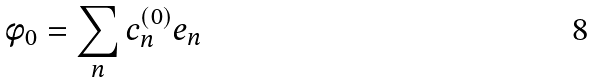Convert formula to latex. <formula><loc_0><loc_0><loc_500><loc_500>\phi _ { 0 } = \sum _ { n } c _ { n } ^ { ( 0 ) } e _ { n }</formula> 